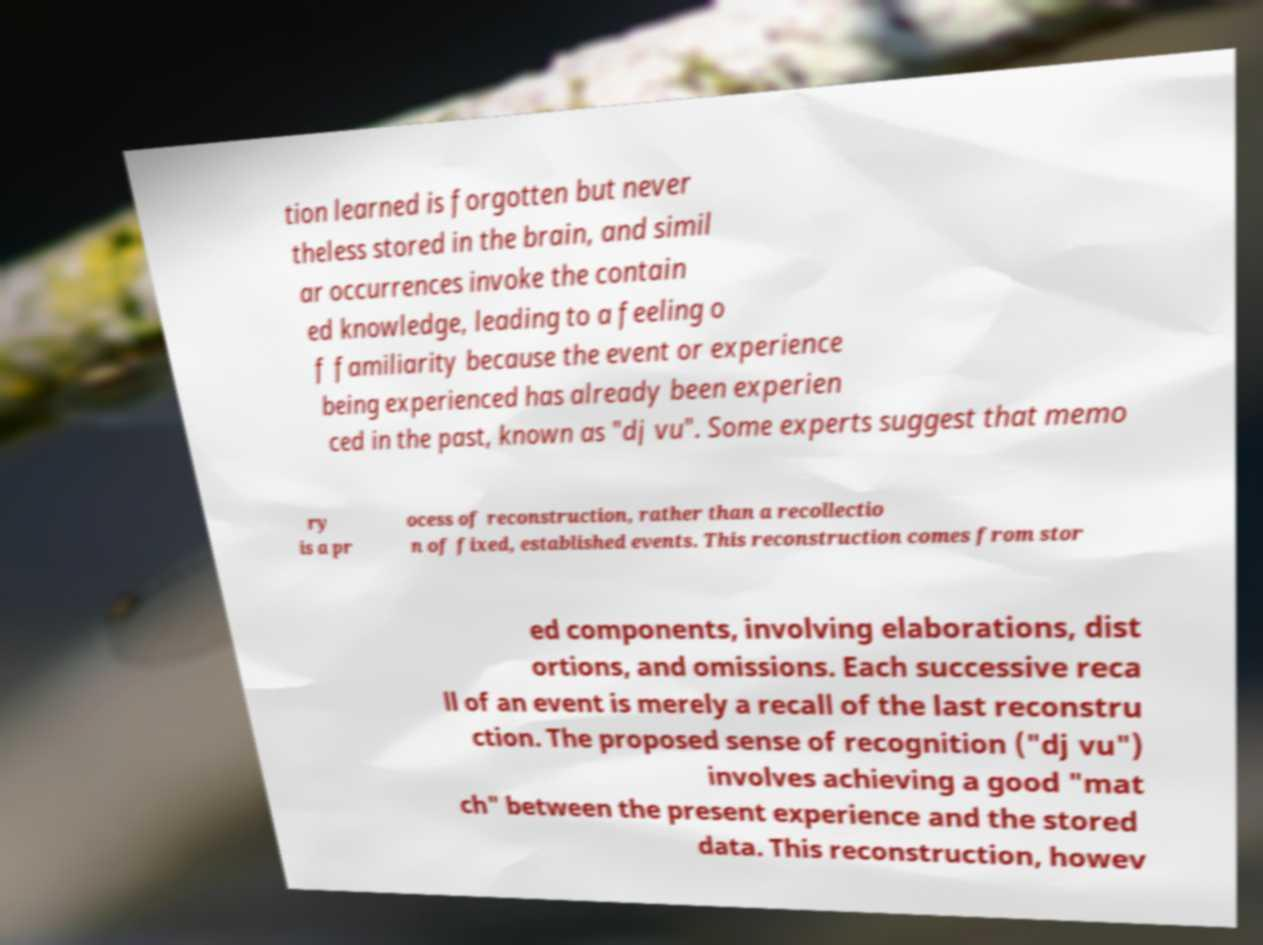Could you extract and type out the text from this image? tion learned is forgotten but never theless stored in the brain, and simil ar occurrences invoke the contain ed knowledge, leading to a feeling o f familiarity because the event or experience being experienced has already been experien ced in the past, known as "dj vu". Some experts suggest that memo ry is a pr ocess of reconstruction, rather than a recollectio n of fixed, established events. This reconstruction comes from stor ed components, involving elaborations, dist ortions, and omissions. Each successive reca ll of an event is merely a recall of the last reconstru ction. The proposed sense of recognition ("dj vu") involves achieving a good "mat ch" between the present experience and the stored data. This reconstruction, howev 